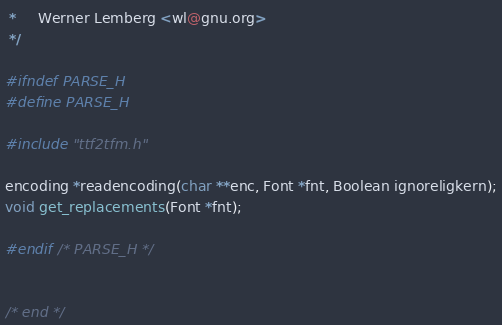Convert code to text. <code><loc_0><loc_0><loc_500><loc_500><_C_> *     Werner Lemberg <wl@gnu.org>
 */

#ifndef PARSE_H
#define PARSE_H

#include "ttf2tfm.h"

encoding *readencoding(char **enc, Font *fnt, Boolean ignoreligkern);
void get_replacements(Font *fnt);

#endif /* PARSE_H */


/* end */
</code> 